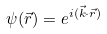<formula> <loc_0><loc_0><loc_500><loc_500>\psi ( \vec { r } ) = e ^ { i ( \vec { k } \cdot \vec { r } ) }</formula> 